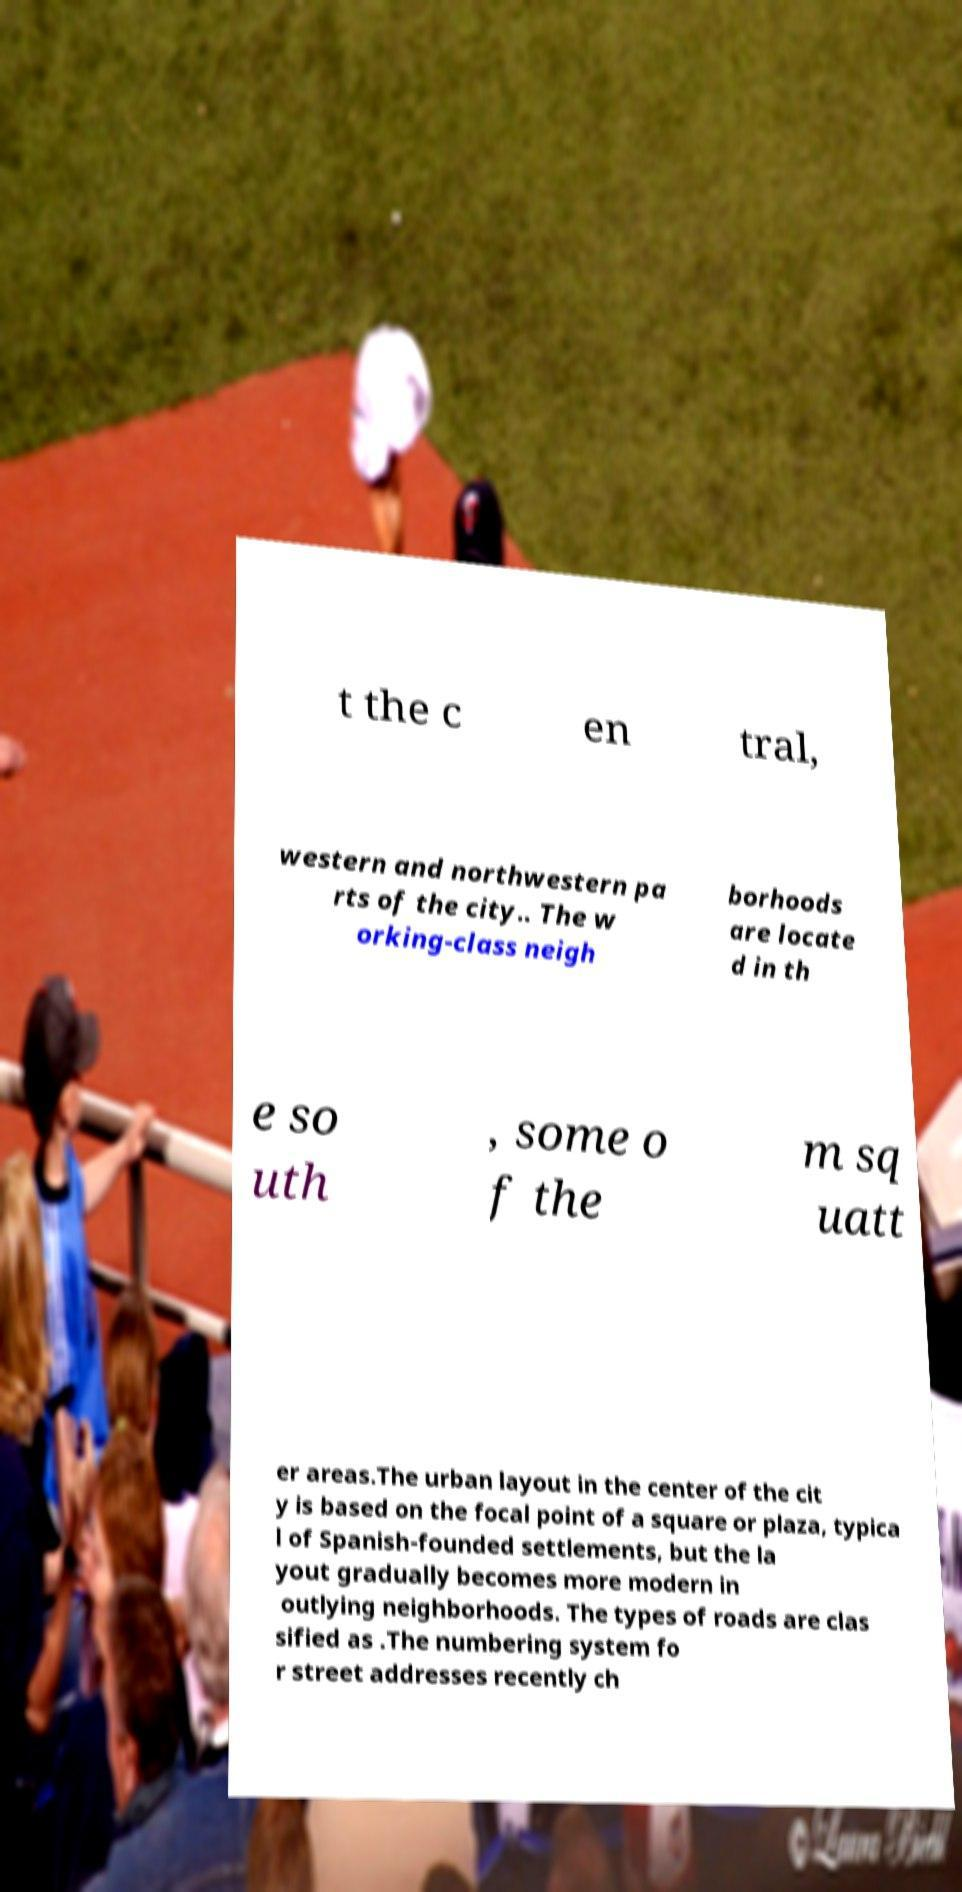Could you assist in decoding the text presented in this image and type it out clearly? t the c en tral, western and northwestern pa rts of the city.. The w orking-class neigh borhoods are locate d in th e so uth , some o f the m sq uatt er areas.The urban layout in the center of the cit y is based on the focal point of a square or plaza, typica l of Spanish-founded settlements, but the la yout gradually becomes more modern in outlying neighborhoods. The types of roads are clas sified as .The numbering system fo r street addresses recently ch 